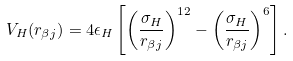<formula> <loc_0><loc_0><loc_500><loc_500>V _ { H } ( r _ { \beta j } ) = 4 \epsilon _ { H } \left [ \left ( \frac { \sigma _ { H } } { r _ { \beta j } } \right ) ^ { 1 2 } - \left ( \frac { \sigma _ { H } } { r _ { \beta j } } \right ) ^ { 6 } \right ] .</formula> 